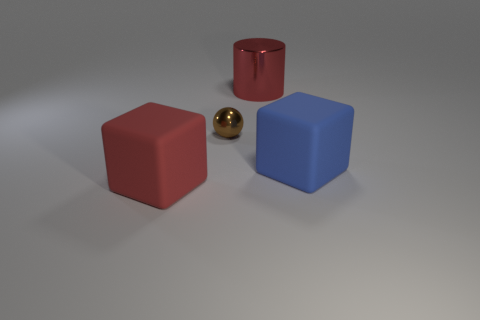The large matte block that is in front of the block to the right of the red thing in front of the blue thing is what color?
Your response must be concise. Red. Does the big red matte object have the same shape as the big blue thing?
Your response must be concise. Yes. What is the color of the large object that is the same material as the large red cube?
Offer a very short reply. Blue. How many things are matte cubes to the left of the blue matte block or tiny metallic spheres?
Offer a terse response. 2. There is a metal thing that is in front of the large red cylinder; what size is it?
Provide a succinct answer. Small. There is a blue rubber block; is it the same size as the shiny object that is in front of the big shiny cylinder?
Offer a very short reply. No. What is the color of the cube that is right of the big red thing on the right side of the big red matte cube?
Your response must be concise. Blue. What number of other objects are there of the same color as the big cylinder?
Offer a terse response. 1. What is the size of the red block?
Provide a succinct answer. Large. Are there more large blocks in front of the large blue thing than metallic cylinders on the left side of the red shiny thing?
Your answer should be very brief. Yes. 